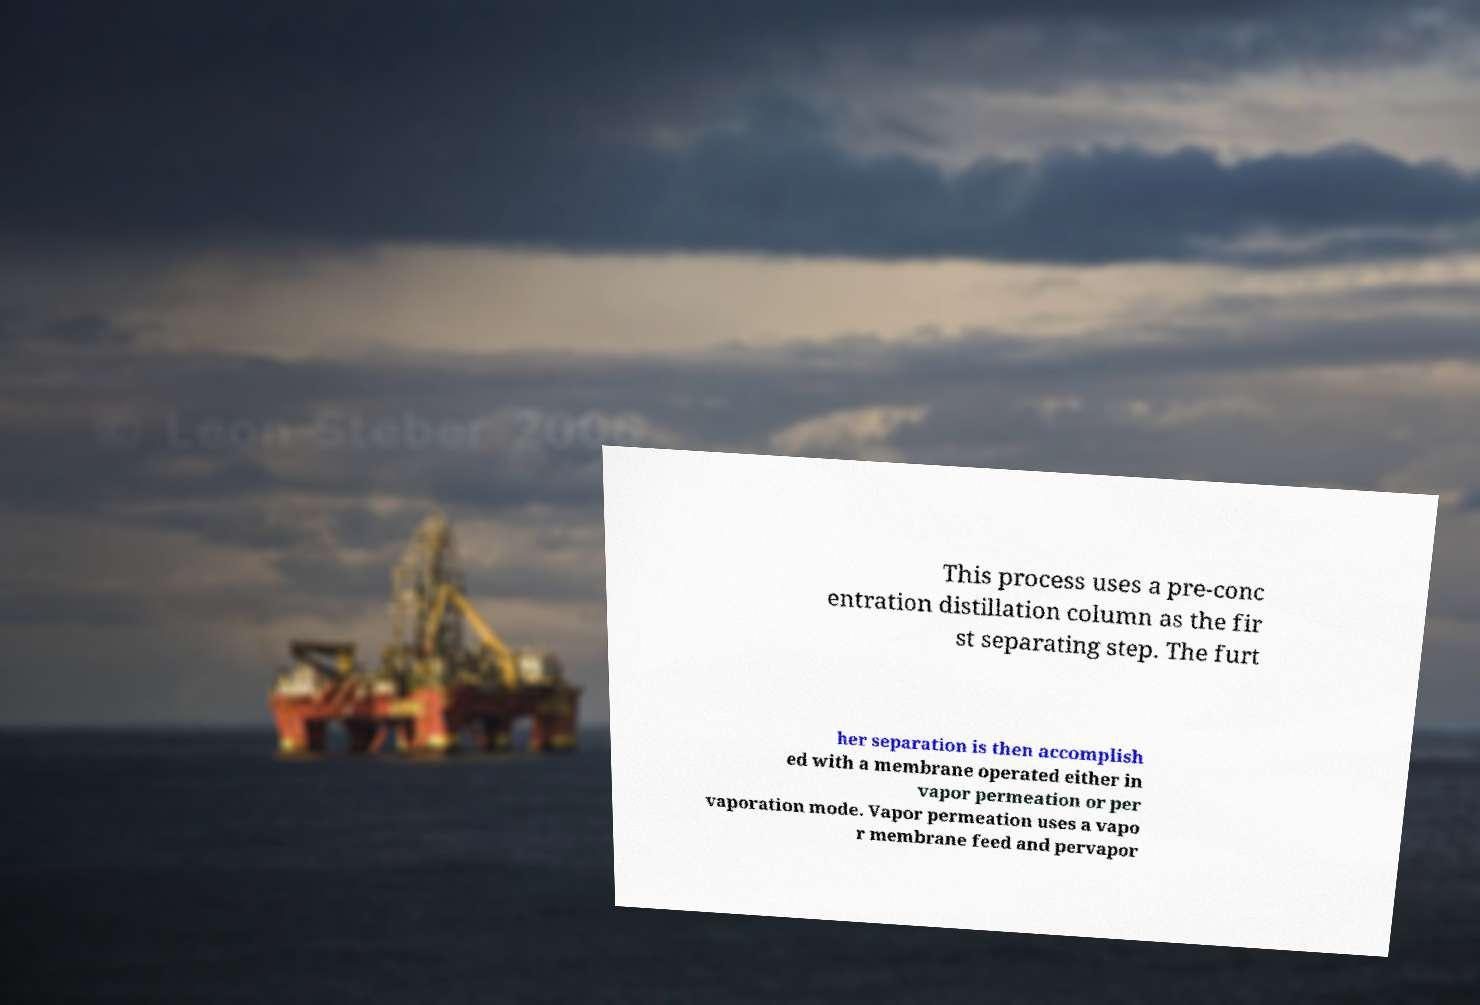There's text embedded in this image that I need extracted. Can you transcribe it verbatim? This process uses a pre-conc entration distillation column as the fir st separating step. The furt her separation is then accomplish ed with a membrane operated either in vapor permeation or per vaporation mode. Vapor permeation uses a vapo r membrane feed and pervapor 